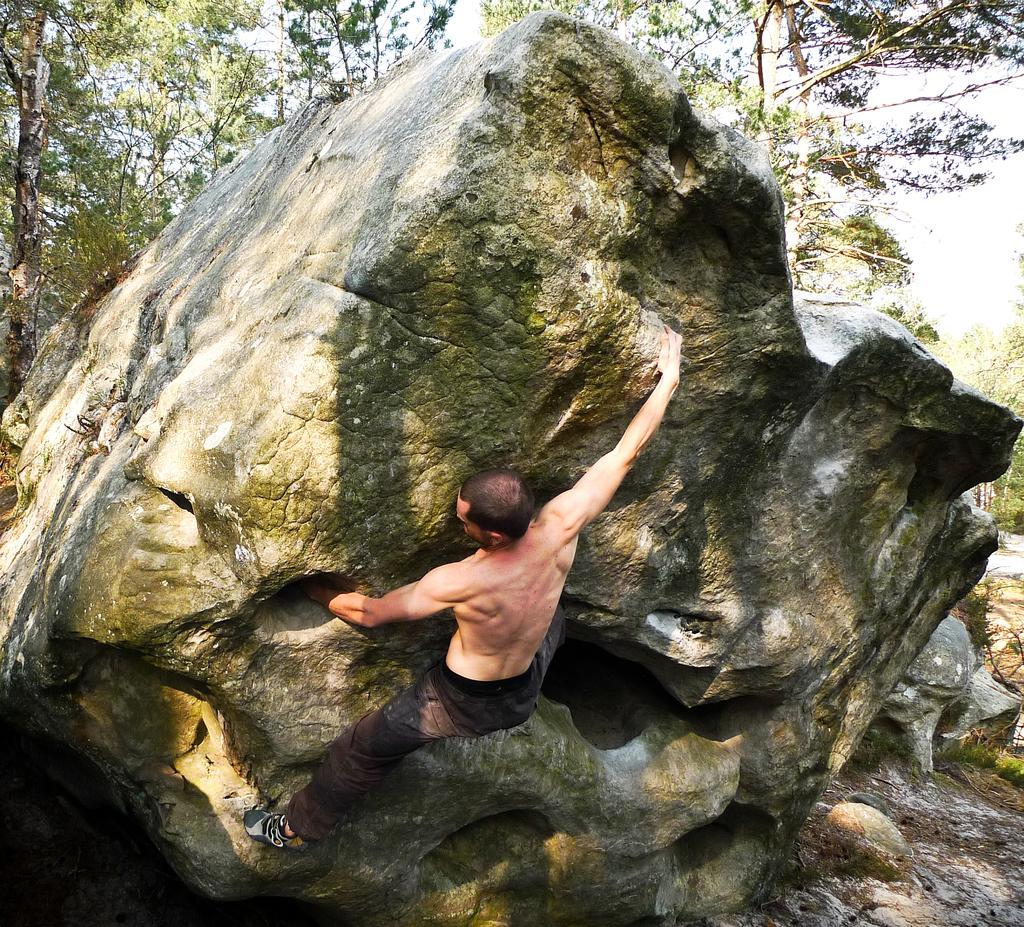What is the person in the image doing? The person is standing on a rock in the image. What can be seen in the background of the image? There are trees in the background of the image. What is visible at the top of the image? The sky is visible at the top of the image. What does the person in the image desire to do with their throat? There is no indication in the image of the person's desires or actions related to their throat. 